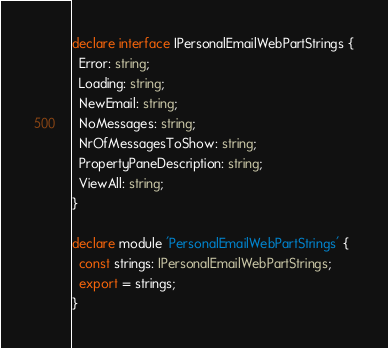<code> <loc_0><loc_0><loc_500><loc_500><_TypeScript_>declare interface IPersonalEmailWebPartStrings {
  Error: string;
  Loading: string;
  NewEmail: string;
  NoMessages: string;
  NrOfMessagesToShow: string;
  PropertyPaneDescription: string;
  ViewAll: string;
}

declare module 'PersonalEmailWebPartStrings' {
  const strings: IPersonalEmailWebPartStrings;
  export = strings;
}
</code> 